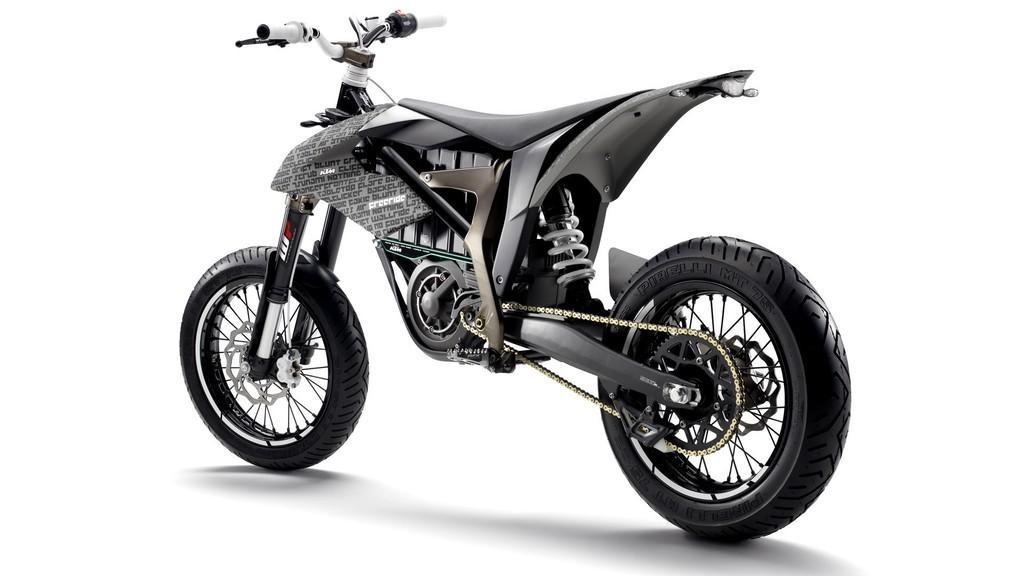Describe this image in one or two sentences. In this image I can see a bicycle with strong wheels. Seems like any other two wheeler scooter. 